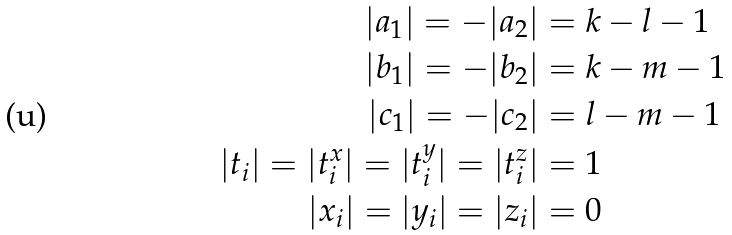Convert formula to latex. <formula><loc_0><loc_0><loc_500><loc_500>| a _ { 1 } | = - | a _ { 2 } | & = k - l - 1 \\ | b _ { 1 } | = - | b _ { 2 } | & = k - m - 1 \\ | c _ { 1 } | = - | c _ { 2 } | & = l - m - 1 \\ | t _ { i } | = | t ^ { x } _ { i } | = | t ^ { y } _ { i } | = | t ^ { z } _ { i } | & = 1 \\ | x _ { i } | = | y _ { i } | = | z _ { i } | & = 0</formula> 